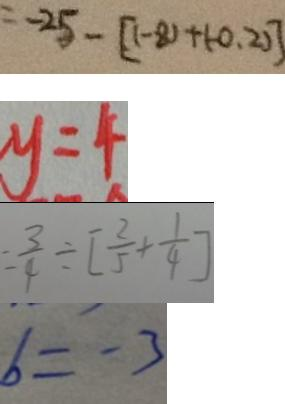<formula> <loc_0><loc_0><loc_500><loc_500>= - 2 5 - [ ( - 8 ) + ( - 0 . 2 ) ] 
 y = 4 
 = \frac { 3 } { 4 } \div [ \frac { 2 } { 5 } + \frac { 1 } { 4 } ] 
 b = - 3</formula> 